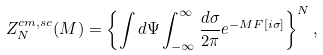Convert formula to latex. <formula><loc_0><loc_0><loc_500><loc_500>Z _ { N } ^ { c m , s c } ( M ) = \left \{ \int d \Psi \int _ { - \infty } ^ { \infty } \frac { d \sigma } { 2 \pi } e ^ { - M F [ i \sigma ] } \right \} ^ { N } ,</formula> 